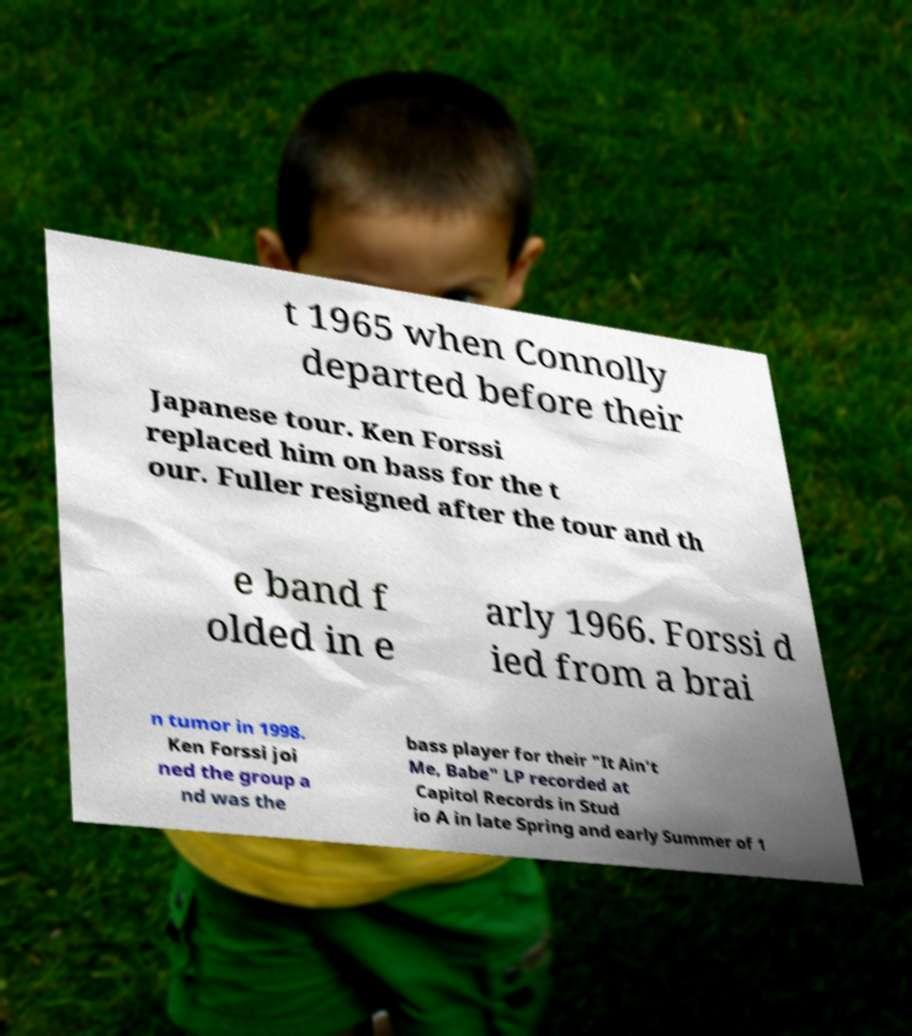I need the written content from this picture converted into text. Can you do that? t 1965 when Connolly departed before their Japanese tour. Ken Forssi replaced him on bass for the t our. Fuller resigned after the tour and th e band f olded in e arly 1966. Forssi d ied from a brai n tumor in 1998. Ken Forssi joi ned the group a nd was the bass player for their "It Ain't Me, Babe" LP recorded at Capitol Records in Stud io A in late Spring and early Summer of 1 